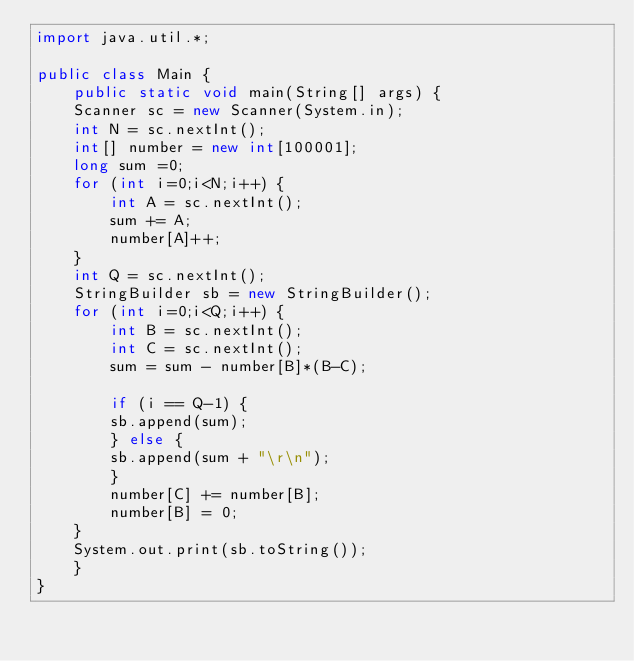Convert code to text. <code><loc_0><loc_0><loc_500><loc_500><_Java_>import java.util.*;

public class Main {
    public static void main(String[] args) {
	Scanner sc = new Scanner(System.in);
	int N = sc.nextInt();
	int[] number = new int[100001];
	long sum =0;
	for (int i=0;i<N;i++) {
	    int A = sc.nextInt();
	    sum += A;
	    number[A]++;
	}
	int Q = sc.nextInt();
	StringBuilder sb = new StringBuilder();
	for (int i=0;i<Q;i++) {
	    int B = sc.nextInt();
	    int C = sc.nextInt();
	    sum = sum - number[B]*(B-C);
	    
	    if (i == Q-1) {
		sb.append(sum);
	    } else {
		sb.append(sum + "\r\n");
	    }
	    number[C] += number[B];
	    number[B] = 0;
	}
	System.out.print(sb.toString());
    }
}
</code> 